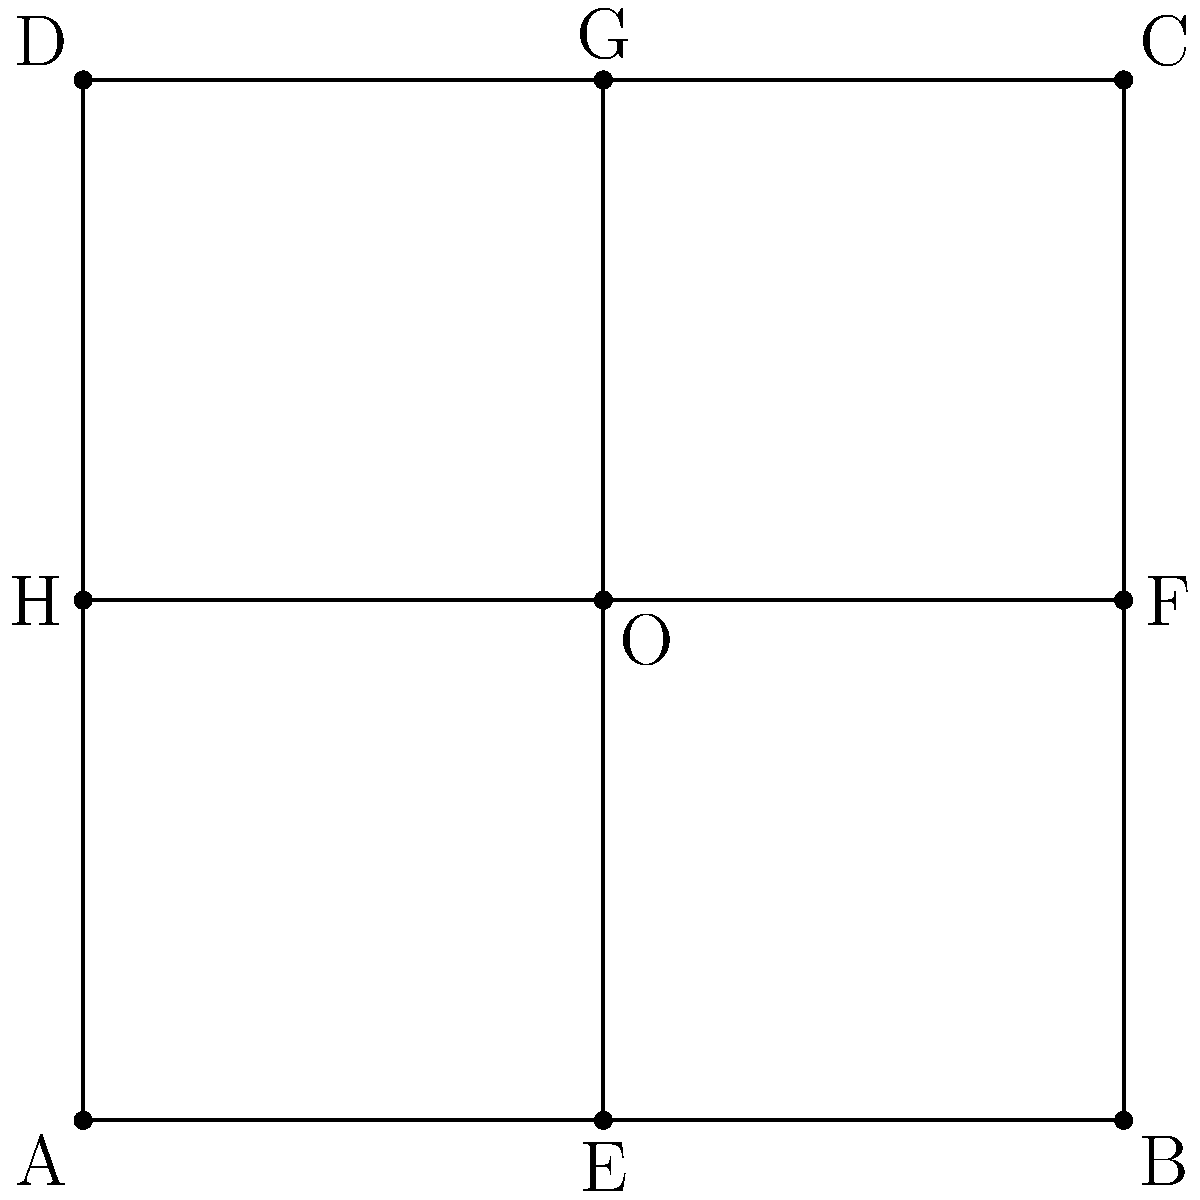A Hypericum stem structure is represented by the square ABCD with its diagonals. If this structure is reflected across the y-axis, x-axis, and the line y=x, which of the following statements is true about the growth pattern analysis?

a) The reflection across the y-axis preserves the orientation of the diagonal EG.
b) The reflection across the x-axis inverts both diagonals EG and HF.
c) The reflection across y=x maintains the perpendicularity of the diagonals.
d) All reflections preserve the area of the square ABCD. Let's analyze each reflection and its effect on the Hypericum stem structure:

1. Reflection across the y-axis:
   - The square ABCD is flipped horizontally.
   - Diagonal EG becomes a vertical line, while HF becomes horizontal.
   - The orientation of EG is not preserved.

2. Reflection across the x-axis:
   - The square ABCD is flipped vertically.
   - Both diagonals EG and HF are inverted.
   - EG becomes a vertical line, while HF becomes horizontal.

3. Reflection across y=x:
   - The square ABCD is flipped diagonally.
   - Diagonals EG and HF swap positions but remain perpendicular to each other.
   - The perpendicularity of the diagonals is maintained.

4. All reflections:
   - Reflections are isometric transformations, meaning they preserve distances and angles.
   - The area of the square ABCD remains constant in all reflections.

Analyzing the given options:
a) False: The reflection across the y-axis changes the orientation of EG.
b) True: The reflection across the x-axis inverts both diagonals EG and HF.
c) True: The reflection across y=x maintains the perpendicularity of the diagonals.
d) True: All reflections preserve the area of the square ABCD.

Therefore, options b, c, and d are correct statements about the growth pattern analysis.
Answer: b, c, and d 